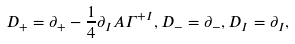<formula> <loc_0><loc_0><loc_500><loc_500>D _ { + } = \partial _ { + } - \frac { 1 } { 4 } \partial _ { I } A \Gamma ^ { + I } , D _ { - } = \partial _ { - } , D _ { I } = \partial _ { I } ,</formula> 